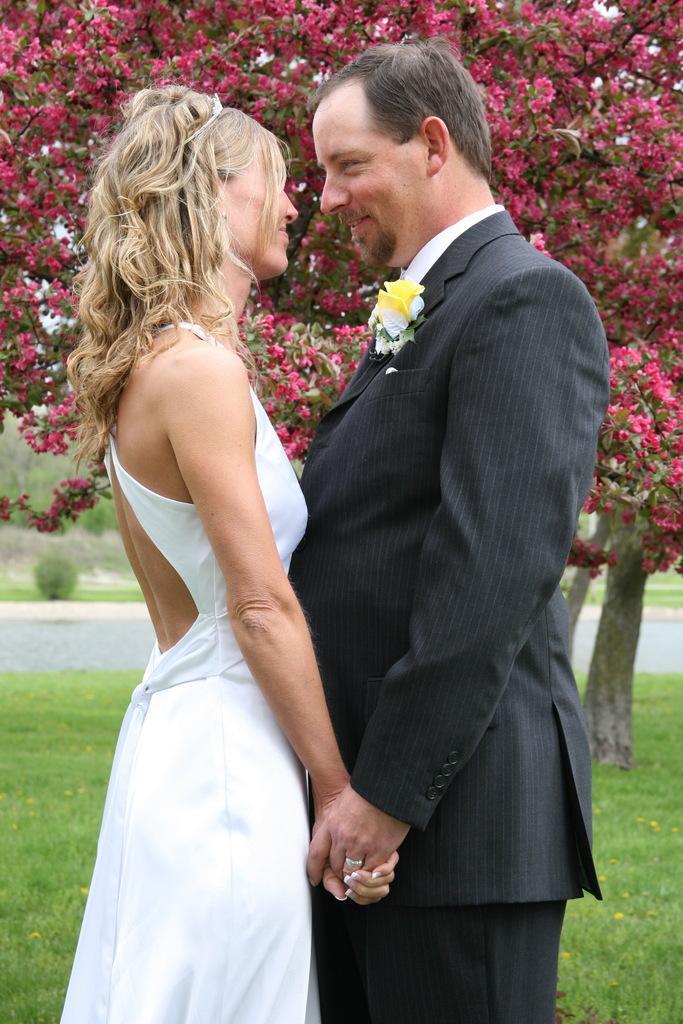How would you summarize this image in a sentence or two? In this image, in the middle, we can see two people man and woman are holding their hands. In the background, we can see some trees, flowers. At the bottom, we can see a road and a grass. 